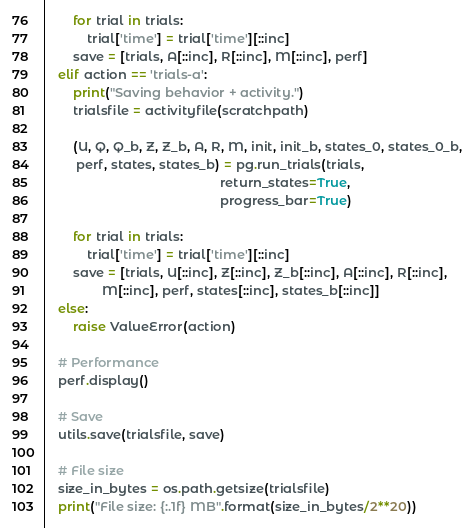<code> <loc_0><loc_0><loc_500><loc_500><_Python_>        for trial in trials:
            trial['time'] = trial['time'][::inc]
        save = [trials, A[::inc], R[::inc], M[::inc], perf]
    elif action == 'trials-a':
        print("Saving behavior + activity.")
        trialsfile = activityfile(scratchpath)

        (U, Q, Q_b, Z, Z_b, A, R, M, init, init_b, states_0, states_0_b,
         perf, states, states_b) = pg.run_trials(trials,
                                                 return_states=True,
                                                 progress_bar=True)

        for trial in trials:
            trial['time'] = trial['time'][::inc]
        save = [trials, U[::inc], Z[::inc], Z_b[::inc], A[::inc], R[::inc],
                M[::inc], perf, states[::inc], states_b[::inc]]
    else:
        raise ValueError(action)

    # Performance
    perf.display()

    # Save
    utils.save(trialsfile, save)

    # File size
    size_in_bytes = os.path.getsize(trialsfile)
    print("File size: {:.1f} MB".format(size_in_bytes/2**20))
</code> 